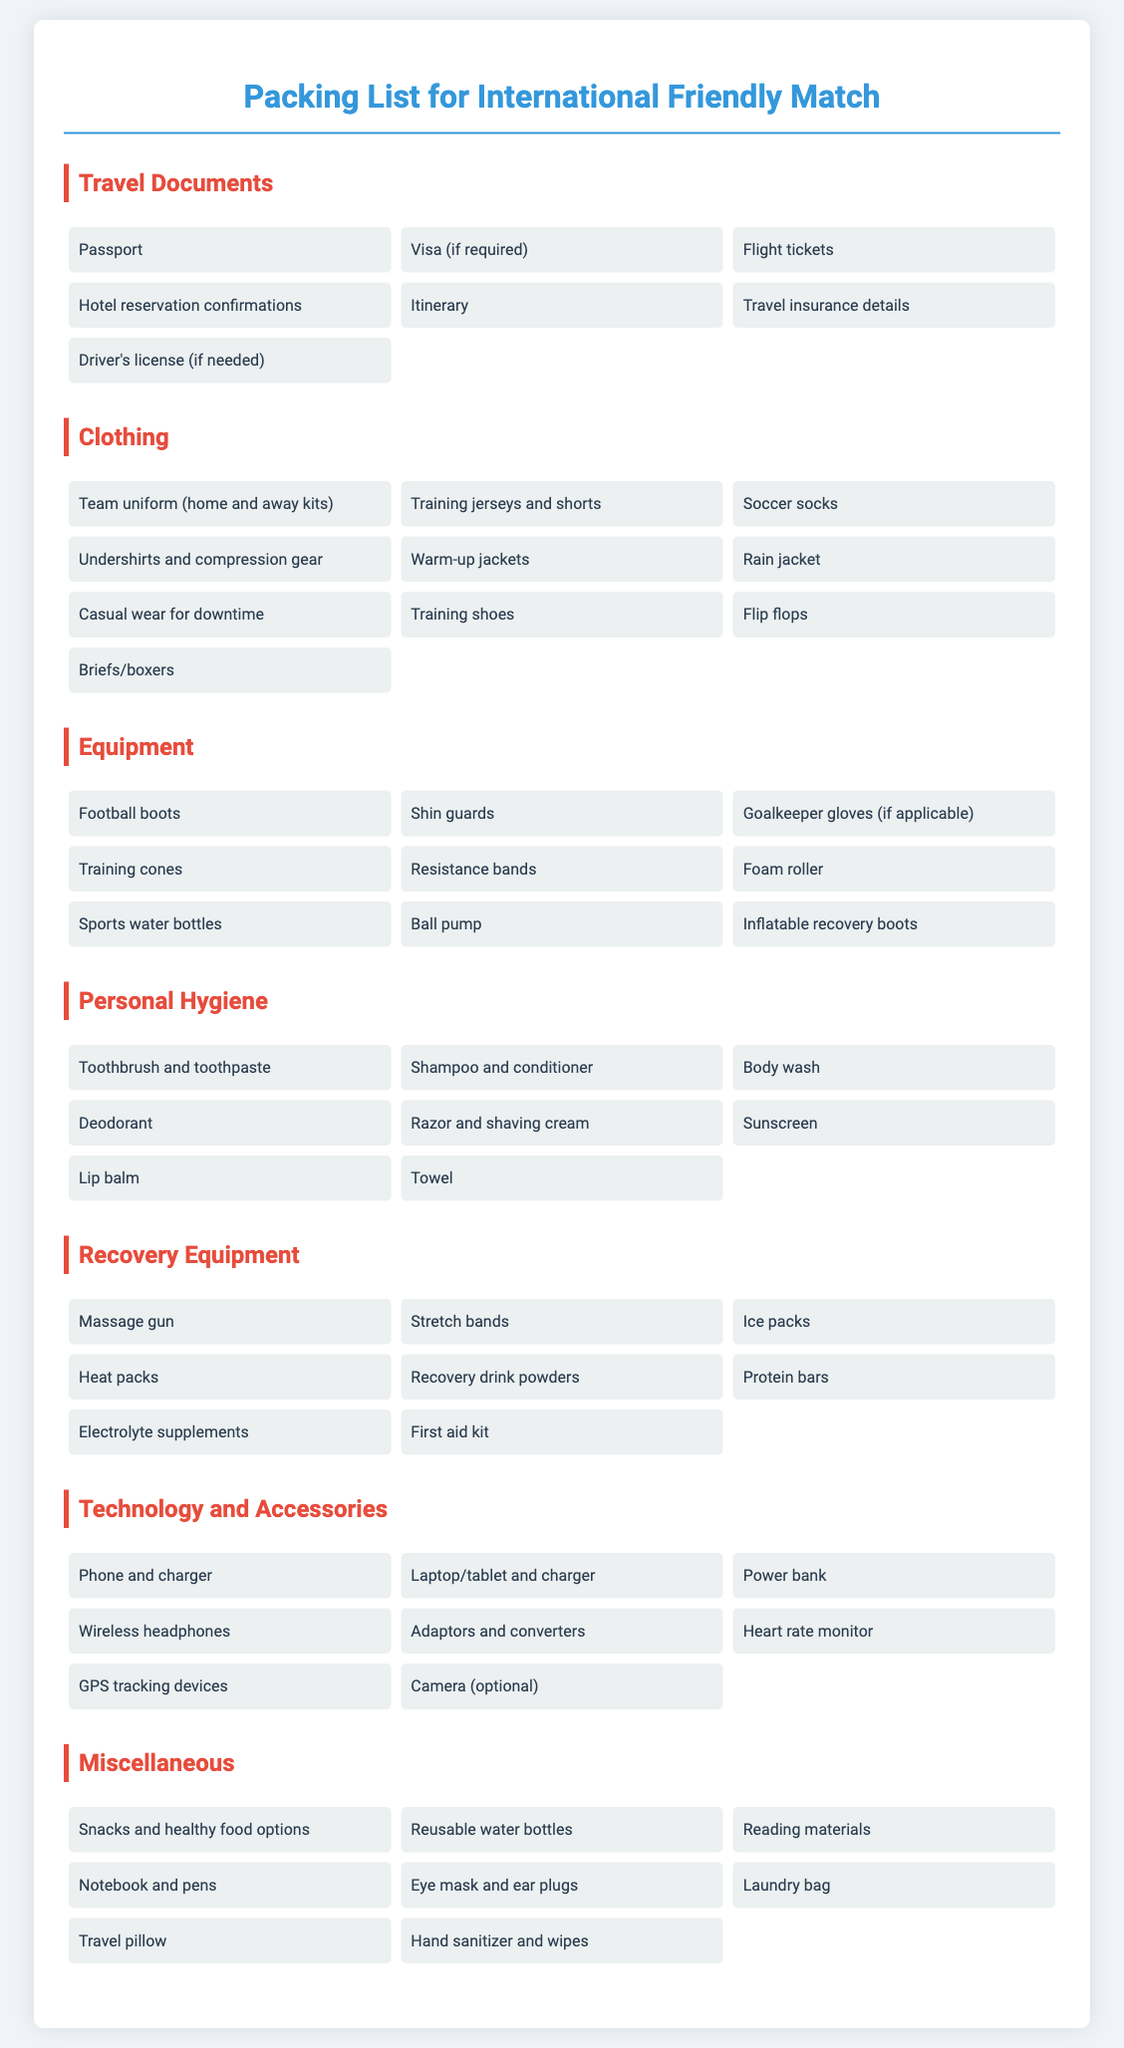What items are included in the Travel Documents category? The Travel Documents category includes essential travel paperwork such as passport, visa (if required), flight tickets, hotel reservation confirmations, itinerary, travel insurance details, and driver's license (if needed).
Answer: Passport, Visa (if required), Flight tickets, Hotel reservation confirmations, Itinerary, Travel insurance details, Driver's license (if needed) How many clothing items are listed? The Clothing category contains a total of ten items related to appropriate attire for the match and travel, which includes team uniforms, training gear, and casual wear.
Answer: 10 Which category includes electrolyte supplements? The electrolyte supplements are mentioned in the Recovery Equipment category, which collects items related to athlete recovery after matches or training.
Answer: Recovery Equipment What equipment is listed for personal hygiene? The Personal Hygiene category includes items that contribute to cleanliness and self-care such as toothbrush and toothpaste, shampoo and conditioner, body wash, and deodorant.
Answer: Toothbrush and toothpaste, Shampoo and conditioner, Body wash, Deodorant What technology item is mentioned in the packing list? The document mentions several technology items, including a phone and charger, laptop/tablet and charger, and a power bank, indicating the need for communication and power during travel.
Answer: Phone and charger How many categories are there in the packing list? The document outlines various packing needs categorized under distinct headings, totaling seven categories, covering all aspects of preparation for a travel match.
Answer: 7 